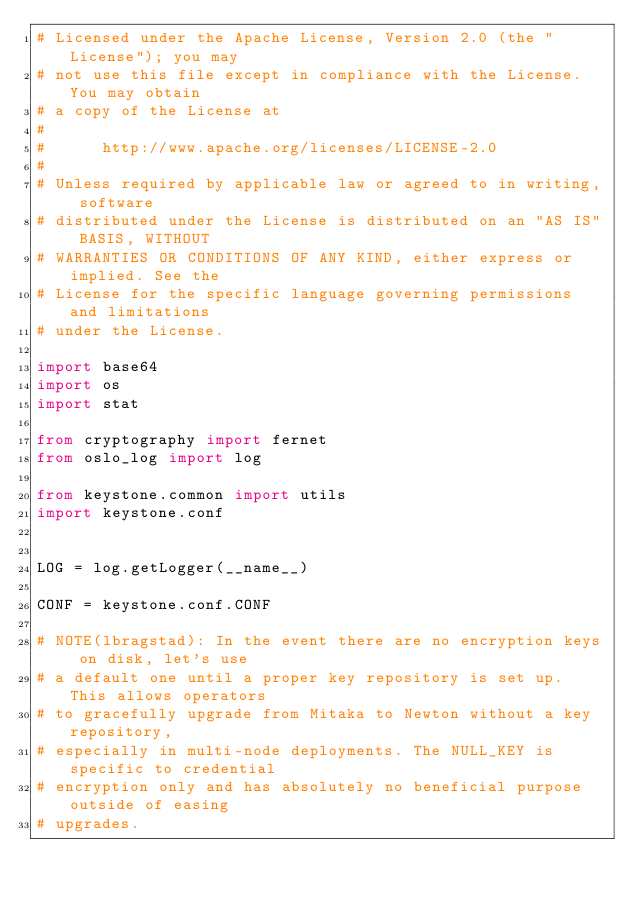Convert code to text. <code><loc_0><loc_0><loc_500><loc_500><_Python_># Licensed under the Apache License, Version 2.0 (the "License"); you may
# not use this file except in compliance with the License. You may obtain
# a copy of the License at
#
#      http://www.apache.org/licenses/LICENSE-2.0
#
# Unless required by applicable law or agreed to in writing, software
# distributed under the License is distributed on an "AS IS" BASIS, WITHOUT
# WARRANTIES OR CONDITIONS OF ANY KIND, either express or implied. See the
# License for the specific language governing permissions and limitations
# under the License.

import base64
import os
import stat

from cryptography import fernet
from oslo_log import log

from keystone.common import utils
import keystone.conf


LOG = log.getLogger(__name__)

CONF = keystone.conf.CONF

# NOTE(lbragstad): In the event there are no encryption keys on disk, let's use
# a default one until a proper key repository is set up. This allows operators
# to gracefully upgrade from Mitaka to Newton without a key repository,
# especially in multi-node deployments. The NULL_KEY is specific to credential
# encryption only and has absolutely no beneficial purpose outside of easing
# upgrades.</code> 